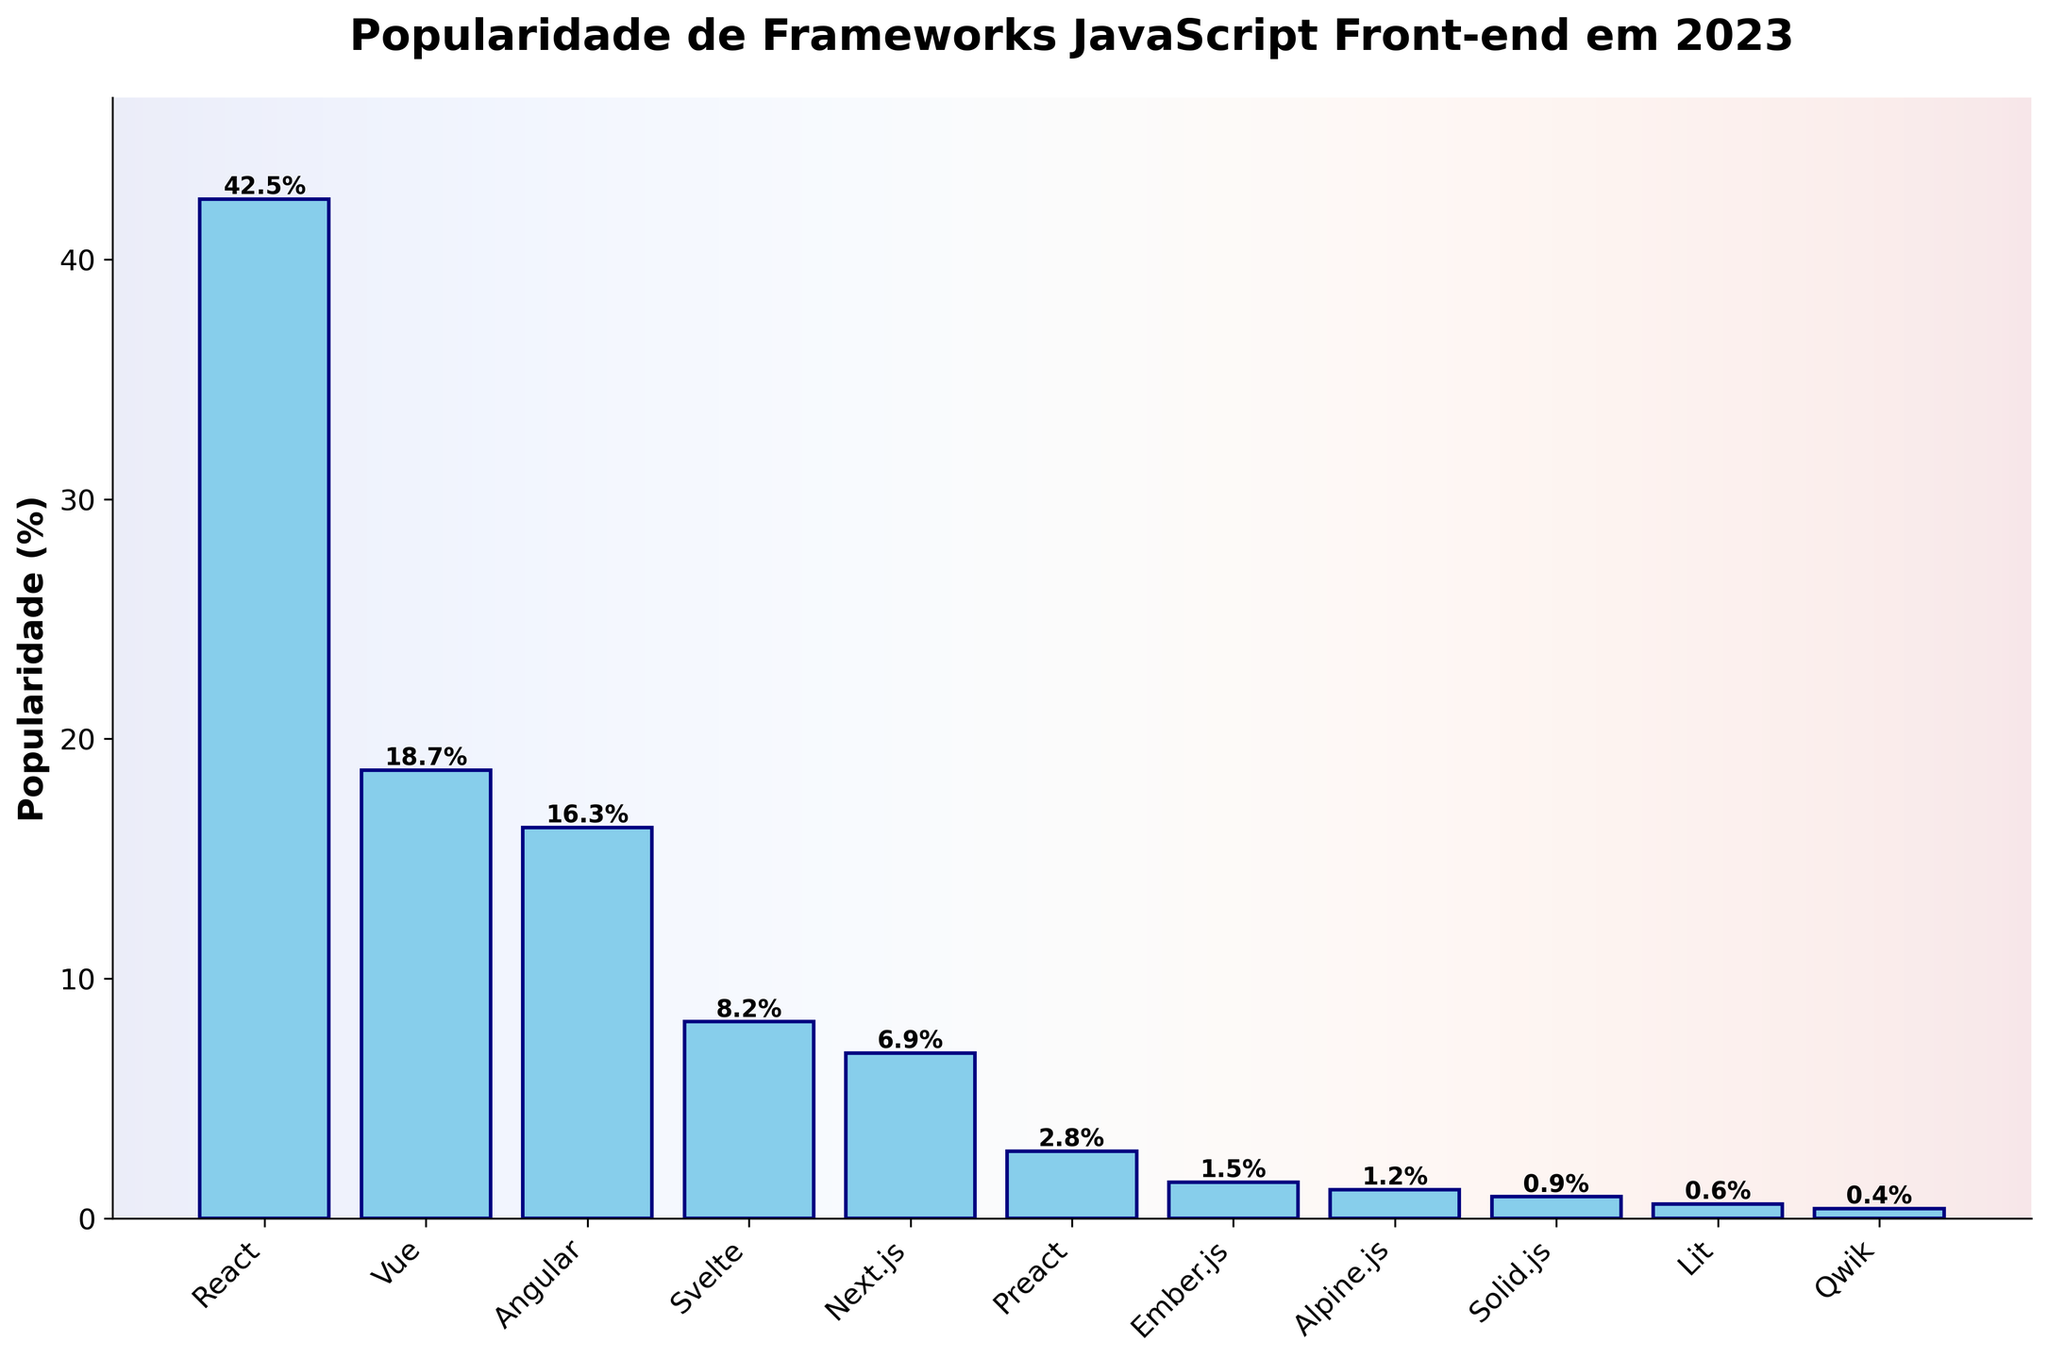Which framework has the highest popularity in 2023? We refer to the figure to identify the highest value on the y-axis. The tallest bar represents the framework with the highest popularity. In this case, React has the highest bar at 42.5%.
Answer: React Which framework is more popular, Vue or Angular? To answer this, look at the bars corresponding to Vue and Angular. Vue has a popularity of 18.7%, while Angular has 16.3%. Since 18.7% is greater than 16.3%, Vue is more popular.
Answer: Vue What is the combined popularity of Svelte and Next.js? To find this, we sum the popularity values of Svelte (8.2%) and Next.js (6.9%). This gives us 8.2% + 6.9% = 15.1%.
Answer: 15.1% Which framework has nearly half the popularity value of React? First, find half of React's popularity, which is 42.5% / 2 = 21.25%. Then, look for the bar closest to this value. In this case, Vue with 18.7% is the closest to 21.25%.
Answer: Vue Which two frameworks have a combined popularity closest to that of React? React has a popularity of 42.5%. We try combinations: Vue (18.7%) + Angular (16.3%) = 35.0%, Svelte (8.2%) + Next.js (6.9%) = 15.1%, and so on. The closest sum is Vue (18.7%) + Angular (16.3%) which equals 35.0%, closest to 42.5%.
Answer: Vue and Angular By how much does Vue's popularity exceed that of Angular? Subtract Angular's popularity from Vue's: 18.7% - 16.3% = 2.4%.
Answer: 2.4% What is the difference in popularity between the least popular framework and the second least popular framework? Identify the least popular framework (Qwik, 0.4%) and the second least popular (Lit, 0.6%), then subtract their values: 0.6% - 0.4% = 0.2%.
Answer: 0.2% Name all frameworks with a popularity below 2%. Refer to the figure, these are Preact (2.8%), Ember.js (1.5%), Alpine.js (1.2%), Solid.js (0.9%), Lit (0.6%), and Qwik (0.4%). However, only those below 2% are Ember.js, Alpine.js, Solid.js, Lit, and Qwik.
Answer: Ember.js, Alpine.js, Solid.js, Lit, Qwik Which framework's bar is 50% taller than that of Next.js? First, calculate 1.5 times the height of Next.js (6.9% * 1.5 = 10.35%). Then find the framework with popularity closest to 10.35%. None of the exact values match, but Svelte has a popularity of 8.2%, the closest relative option in the figure.
Answer: No exact match If Svelte and Preact's popularity percentages were combined, would they surpass Angular? Combine the values of Svelte (8.2%) and Preact (2.8%), which equals 11%. Compare this with Angular's popularity of 16.3%. Since 11% < 16.3%, it does not surpass Angular.
Answer: No Which framework shows a visually significant gap in popularity compared to Lit? Identify all frameworks, then look at Lit (0.6%) and compare it angularly to others. The most visually significant gap, in relative terms, stems from frameworks like React (42.5%), as the bars have notable differing heights.
Answer: React 